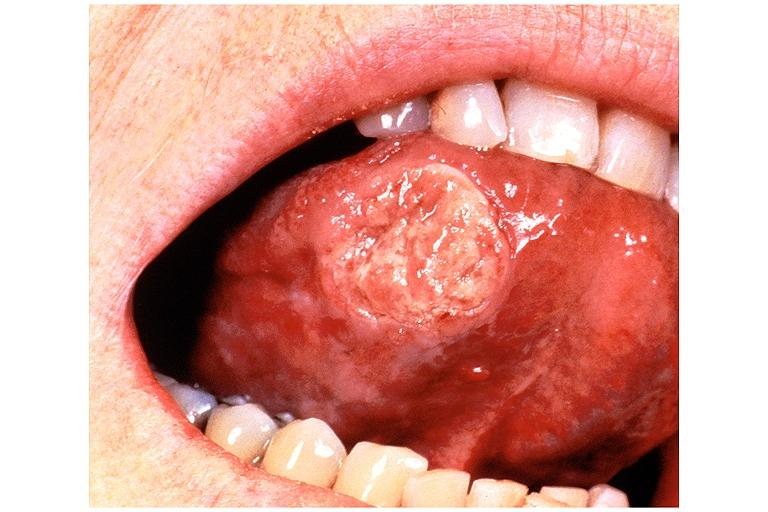where is this?
Answer the question using a single word or phrase. Oral 